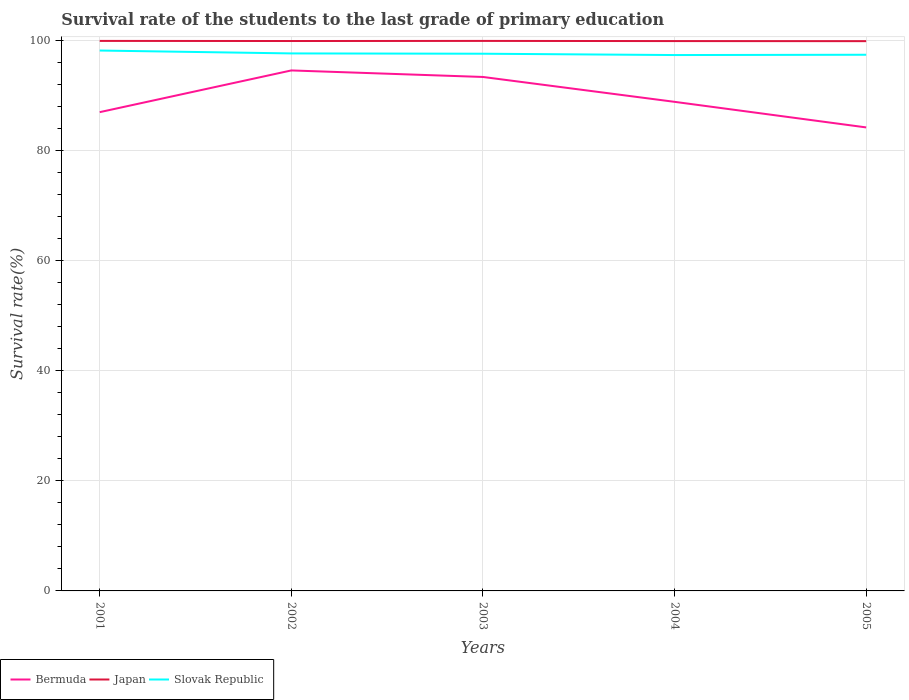Across all years, what is the maximum survival rate of the students in Bermuda?
Ensure brevity in your answer.  84.24. In which year was the survival rate of the students in Japan maximum?
Give a very brief answer. 2005. What is the total survival rate of the students in Slovak Republic in the graph?
Offer a terse response. 0.53. What is the difference between the highest and the second highest survival rate of the students in Bermuda?
Give a very brief answer. 10.36. What is the difference between the highest and the lowest survival rate of the students in Bermuda?
Your answer should be very brief. 2. Does the graph contain any zero values?
Your answer should be very brief. No. Does the graph contain grids?
Keep it short and to the point. Yes. How are the legend labels stacked?
Keep it short and to the point. Horizontal. What is the title of the graph?
Your response must be concise. Survival rate of the students to the last grade of primary education. Does "Benin" appear as one of the legend labels in the graph?
Ensure brevity in your answer.  No. What is the label or title of the X-axis?
Provide a short and direct response. Years. What is the label or title of the Y-axis?
Your answer should be compact. Survival rate(%). What is the Survival rate(%) in Bermuda in 2001?
Provide a short and direct response. 87.02. What is the Survival rate(%) of Japan in 2001?
Give a very brief answer. 99.97. What is the Survival rate(%) of Slovak Republic in 2001?
Provide a short and direct response. 98.22. What is the Survival rate(%) in Bermuda in 2002?
Offer a very short reply. 94.6. What is the Survival rate(%) of Japan in 2002?
Your answer should be very brief. 99.95. What is the Survival rate(%) of Slovak Republic in 2002?
Give a very brief answer. 97.69. What is the Survival rate(%) of Bermuda in 2003?
Your answer should be compact. 93.41. What is the Survival rate(%) in Japan in 2003?
Your answer should be very brief. 99.97. What is the Survival rate(%) in Slovak Republic in 2003?
Provide a short and direct response. 97.64. What is the Survival rate(%) in Bermuda in 2004?
Your response must be concise. 88.89. What is the Survival rate(%) in Japan in 2004?
Offer a very short reply. 99.93. What is the Survival rate(%) of Slovak Republic in 2004?
Your response must be concise. 97.4. What is the Survival rate(%) in Bermuda in 2005?
Give a very brief answer. 84.24. What is the Survival rate(%) of Japan in 2005?
Keep it short and to the point. 99.92. What is the Survival rate(%) in Slovak Republic in 2005?
Keep it short and to the point. 97.45. Across all years, what is the maximum Survival rate(%) in Bermuda?
Offer a terse response. 94.6. Across all years, what is the maximum Survival rate(%) of Japan?
Provide a short and direct response. 99.97. Across all years, what is the maximum Survival rate(%) in Slovak Republic?
Give a very brief answer. 98.22. Across all years, what is the minimum Survival rate(%) of Bermuda?
Your response must be concise. 84.24. Across all years, what is the minimum Survival rate(%) in Japan?
Keep it short and to the point. 99.92. Across all years, what is the minimum Survival rate(%) of Slovak Republic?
Offer a terse response. 97.4. What is the total Survival rate(%) of Bermuda in the graph?
Offer a very short reply. 448.16. What is the total Survival rate(%) of Japan in the graph?
Ensure brevity in your answer.  499.73. What is the total Survival rate(%) of Slovak Republic in the graph?
Give a very brief answer. 488.39. What is the difference between the Survival rate(%) in Bermuda in 2001 and that in 2002?
Your answer should be very brief. -7.58. What is the difference between the Survival rate(%) of Japan in 2001 and that in 2002?
Provide a short and direct response. 0.02. What is the difference between the Survival rate(%) of Slovak Republic in 2001 and that in 2002?
Provide a short and direct response. 0.53. What is the difference between the Survival rate(%) of Bermuda in 2001 and that in 2003?
Provide a succinct answer. -6.39. What is the difference between the Survival rate(%) in Japan in 2001 and that in 2003?
Make the answer very short. -0. What is the difference between the Survival rate(%) in Slovak Republic in 2001 and that in 2003?
Your response must be concise. 0.58. What is the difference between the Survival rate(%) in Bermuda in 2001 and that in 2004?
Keep it short and to the point. -1.87. What is the difference between the Survival rate(%) of Japan in 2001 and that in 2004?
Provide a succinct answer. 0.03. What is the difference between the Survival rate(%) in Slovak Republic in 2001 and that in 2004?
Offer a very short reply. 0.82. What is the difference between the Survival rate(%) in Bermuda in 2001 and that in 2005?
Make the answer very short. 2.77. What is the difference between the Survival rate(%) in Japan in 2001 and that in 2005?
Ensure brevity in your answer.  0.05. What is the difference between the Survival rate(%) in Slovak Republic in 2001 and that in 2005?
Provide a short and direct response. 0.77. What is the difference between the Survival rate(%) in Bermuda in 2002 and that in 2003?
Keep it short and to the point. 1.19. What is the difference between the Survival rate(%) in Japan in 2002 and that in 2003?
Your answer should be very brief. -0.02. What is the difference between the Survival rate(%) in Slovak Republic in 2002 and that in 2003?
Offer a terse response. 0.05. What is the difference between the Survival rate(%) in Bermuda in 2002 and that in 2004?
Your response must be concise. 5.71. What is the difference between the Survival rate(%) in Japan in 2002 and that in 2004?
Give a very brief answer. 0.01. What is the difference between the Survival rate(%) of Slovak Republic in 2002 and that in 2004?
Your response must be concise. 0.29. What is the difference between the Survival rate(%) in Bermuda in 2002 and that in 2005?
Make the answer very short. 10.36. What is the difference between the Survival rate(%) in Japan in 2002 and that in 2005?
Offer a terse response. 0.03. What is the difference between the Survival rate(%) of Slovak Republic in 2002 and that in 2005?
Ensure brevity in your answer.  0.24. What is the difference between the Survival rate(%) in Bermuda in 2003 and that in 2004?
Your answer should be very brief. 4.52. What is the difference between the Survival rate(%) in Japan in 2003 and that in 2004?
Your answer should be compact. 0.03. What is the difference between the Survival rate(%) of Slovak Republic in 2003 and that in 2004?
Provide a short and direct response. 0.24. What is the difference between the Survival rate(%) of Bermuda in 2003 and that in 2005?
Give a very brief answer. 9.17. What is the difference between the Survival rate(%) of Japan in 2003 and that in 2005?
Provide a succinct answer. 0.05. What is the difference between the Survival rate(%) in Slovak Republic in 2003 and that in 2005?
Your response must be concise. 0.19. What is the difference between the Survival rate(%) in Bermuda in 2004 and that in 2005?
Your answer should be compact. 4.65. What is the difference between the Survival rate(%) of Japan in 2004 and that in 2005?
Offer a very short reply. 0.01. What is the difference between the Survival rate(%) of Slovak Republic in 2004 and that in 2005?
Ensure brevity in your answer.  -0.05. What is the difference between the Survival rate(%) in Bermuda in 2001 and the Survival rate(%) in Japan in 2002?
Ensure brevity in your answer.  -12.93. What is the difference between the Survival rate(%) in Bermuda in 2001 and the Survival rate(%) in Slovak Republic in 2002?
Provide a short and direct response. -10.67. What is the difference between the Survival rate(%) of Japan in 2001 and the Survival rate(%) of Slovak Republic in 2002?
Your answer should be compact. 2.28. What is the difference between the Survival rate(%) of Bermuda in 2001 and the Survival rate(%) of Japan in 2003?
Keep it short and to the point. -12.95. What is the difference between the Survival rate(%) of Bermuda in 2001 and the Survival rate(%) of Slovak Republic in 2003?
Your answer should be very brief. -10.62. What is the difference between the Survival rate(%) of Japan in 2001 and the Survival rate(%) of Slovak Republic in 2003?
Give a very brief answer. 2.33. What is the difference between the Survival rate(%) in Bermuda in 2001 and the Survival rate(%) in Japan in 2004?
Give a very brief answer. -12.92. What is the difference between the Survival rate(%) in Bermuda in 2001 and the Survival rate(%) in Slovak Republic in 2004?
Make the answer very short. -10.38. What is the difference between the Survival rate(%) of Japan in 2001 and the Survival rate(%) of Slovak Republic in 2004?
Keep it short and to the point. 2.57. What is the difference between the Survival rate(%) of Bermuda in 2001 and the Survival rate(%) of Japan in 2005?
Offer a terse response. -12.9. What is the difference between the Survival rate(%) in Bermuda in 2001 and the Survival rate(%) in Slovak Republic in 2005?
Your response must be concise. -10.43. What is the difference between the Survival rate(%) in Japan in 2001 and the Survival rate(%) in Slovak Republic in 2005?
Give a very brief answer. 2.52. What is the difference between the Survival rate(%) of Bermuda in 2002 and the Survival rate(%) of Japan in 2003?
Your answer should be very brief. -5.37. What is the difference between the Survival rate(%) of Bermuda in 2002 and the Survival rate(%) of Slovak Republic in 2003?
Your answer should be compact. -3.04. What is the difference between the Survival rate(%) of Japan in 2002 and the Survival rate(%) of Slovak Republic in 2003?
Give a very brief answer. 2.31. What is the difference between the Survival rate(%) of Bermuda in 2002 and the Survival rate(%) of Japan in 2004?
Your answer should be compact. -5.33. What is the difference between the Survival rate(%) in Bermuda in 2002 and the Survival rate(%) in Slovak Republic in 2004?
Offer a very short reply. -2.8. What is the difference between the Survival rate(%) of Japan in 2002 and the Survival rate(%) of Slovak Republic in 2004?
Ensure brevity in your answer.  2.55. What is the difference between the Survival rate(%) of Bermuda in 2002 and the Survival rate(%) of Japan in 2005?
Keep it short and to the point. -5.32. What is the difference between the Survival rate(%) in Bermuda in 2002 and the Survival rate(%) in Slovak Republic in 2005?
Give a very brief answer. -2.85. What is the difference between the Survival rate(%) in Japan in 2002 and the Survival rate(%) in Slovak Republic in 2005?
Make the answer very short. 2.5. What is the difference between the Survival rate(%) of Bermuda in 2003 and the Survival rate(%) of Japan in 2004?
Keep it short and to the point. -6.52. What is the difference between the Survival rate(%) in Bermuda in 2003 and the Survival rate(%) in Slovak Republic in 2004?
Your answer should be very brief. -3.98. What is the difference between the Survival rate(%) of Japan in 2003 and the Survival rate(%) of Slovak Republic in 2004?
Make the answer very short. 2.57. What is the difference between the Survival rate(%) of Bermuda in 2003 and the Survival rate(%) of Japan in 2005?
Provide a short and direct response. -6.51. What is the difference between the Survival rate(%) of Bermuda in 2003 and the Survival rate(%) of Slovak Republic in 2005?
Offer a very short reply. -4.04. What is the difference between the Survival rate(%) in Japan in 2003 and the Survival rate(%) in Slovak Republic in 2005?
Your answer should be very brief. 2.52. What is the difference between the Survival rate(%) in Bermuda in 2004 and the Survival rate(%) in Japan in 2005?
Offer a very short reply. -11.03. What is the difference between the Survival rate(%) of Bermuda in 2004 and the Survival rate(%) of Slovak Republic in 2005?
Ensure brevity in your answer.  -8.56. What is the difference between the Survival rate(%) of Japan in 2004 and the Survival rate(%) of Slovak Republic in 2005?
Your answer should be very brief. 2.49. What is the average Survival rate(%) in Bermuda per year?
Give a very brief answer. 89.63. What is the average Survival rate(%) of Japan per year?
Offer a very short reply. 99.95. What is the average Survival rate(%) of Slovak Republic per year?
Your answer should be very brief. 97.68. In the year 2001, what is the difference between the Survival rate(%) of Bermuda and Survival rate(%) of Japan?
Provide a short and direct response. -12.95. In the year 2001, what is the difference between the Survival rate(%) of Bermuda and Survival rate(%) of Slovak Republic?
Ensure brevity in your answer.  -11.2. In the year 2001, what is the difference between the Survival rate(%) of Japan and Survival rate(%) of Slovak Republic?
Keep it short and to the point. 1.75. In the year 2002, what is the difference between the Survival rate(%) in Bermuda and Survival rate(%) in Japan?
Ensure brevity in your answer.  -5.35. In the year 2002, what is the difference between the Survival rate(%) in Bermuda and Survival rate(%) in Slovak Republic?
Give a very brief answer. -3.09. In the year 2002, what is the difference between the Survival rate(%) of Japan and Survival rate(%) of Slovak Republic?
Keep it short and to the point. 2.26. In the year 2003, what is the difference between the Survival rate(%) in Bermuda and Survival rate(%) in Japan?
Provide a succinct answer. -6.56. In the year 2003, what is the difference between the Survival rate(%) of Bermuda and Survival rate(%) of Slovak Republic?
Make the answer very short. -4.22. In the year 2003, what is the difference between the Survival rate(%) of Japan and Survival rate(%) of Slovak Republic?
Provide a succinct answer. 2.33. In the year 2004, what is the difference between the Survival rate(%) in Bermuda and Survival rate(%) in Japan?
Offer a terse response. -11.04. In the year 2004, what is the difference between the Survival rate(%) in Bermuda and Survival rate(%) in Slovak Republic?
Offer a very short reply. -8.5. In the year 2004, what is the difference between the Survival rate(%) of Japan and Survival rate(%) of Slovak Republic?
Provide a succinct answer. 2.54. In the year 2005, what is the difference between the Survival rate(%) in Bermuda and Survival rate(%) in Japan?
Provide a succinct answer. -15.68. In the year 2005, what is the difference between the Survival rate(%) of Bermuda and Survival rate(%) of Slovak Republic?
Provide a short and direct response. -13.21. In the year 2005, what is the difference between the Survival rate(%) in Japan and Survival rate(%) in Slovak Republic?
Give a very brief answer. 2.47. What is the ratio of the Survival rate(%) of Bermuda in 2001 to that in 2002?
Make the answer very short. 0.92. What is the ratio of the Survival rate(%) of Slovak Republic in 2001 to that in 2002?
Keep it short and to the point. 1.01. What is the ratio of the Survival rate(%) in Bermuda in 2001 to that in 2003?
Your response must be concise. 0.93. What is the ratio of the Survival rate(%) of Slovak Republic in 2001 to that in 2003?
Offer a terse response. 1.01. What is the ratio of the Survival rate(%) in Bermuda in 2001 to that in 2004?
Provide a short and direct response. 0.98. What is the ratio of the Survival rate(%) of Japan in 2001 to that in 2004?
Offer a very short reply. 1. What is the ratio of the Survival rate(%) in Slovak Republic in 2001 to that in 2004?
Offer a very short reply. 1.01. What is the ratio of the Survival rate(%) in Bermuda in 2001 to that in 2005?
Offer a very short reply. 1.03. What is the ratio of the Survival rate(%) of Slovak Republic in 2001 to that in 2005?
Your answer should be compact. 1.01. What is the ratio of the Survival rate(%) in Bermuda in 2002 to that in 2003?
Offer a terse response. 1.01. What is the ratio of the Survival rate(%) of Japan in 2002 to that in 2003?
Your answer should be compact. 1. What is the ratio of the Survival rate(%) of Slovak Republic in 2002 to that in 2003?
Offer a terse response. 1. What is the ratio of the Survival rate(%) of Bermuda in 2002 to that in 2004?
Provide a succinct answer. 1.06. What is the ratio of the Survival rate(%) in Slovak Republic in 2002 to that in 2004?
Make the answer very short. 1. What is the ratio of the Survival rate(%) in Bermuda in 2002 to that in 2005?
Provide a succinct answer. 1.12. What is the ratio of the Survival rate(%) of Japan in 2002 to that in 2005?
Provide a succinct answer. 1. What is the ratio of the Survival rate(%) in Slovak Republic in 2002 to that in 2005?
Your response must be concise. 1. What is the ratio of the Survival rate(%) of Bermuda in 2003 to that in 2004?
Provide a succinct answer. 1.05. What is the ratio of the Survival rate(%) in Bermuda in 2003 to that in 2005?
Your answer should be compact. 1.11. What is the ratio of the Survival rate(%) in Bermuda in 2004 to that in 2005?
Ensure brevity in your answer.  1.06. What is the ratio of the Survival rate(%) in Japan in 2004 to that in 2005?
Offer a very short reply. 1. What is the difference between the highest and the second highest Survival rate(%) of Bermuda?
Your answer should be very brief. 1.19. What is the difference between the highest and the second highest Survival rate(%) in Japan?
Make the answer very short. 0. What is the difference between the highest and the second highest Survival rate(%) in Slovak Republic?
Offer a terse response. 0.53. What is the difference between the highest and the lowest Survival rate(%) in Bermuda?
Offer a very short reply. 10.36. What is the difference between the highest and the lowest Survival rate(%) of Japan?
Offer a very short reply. 0.05. What is the difference between the highest and the lowest Survival rate(%) in Slovak Republic?
Ensure brevity in your answer.  0.82. 